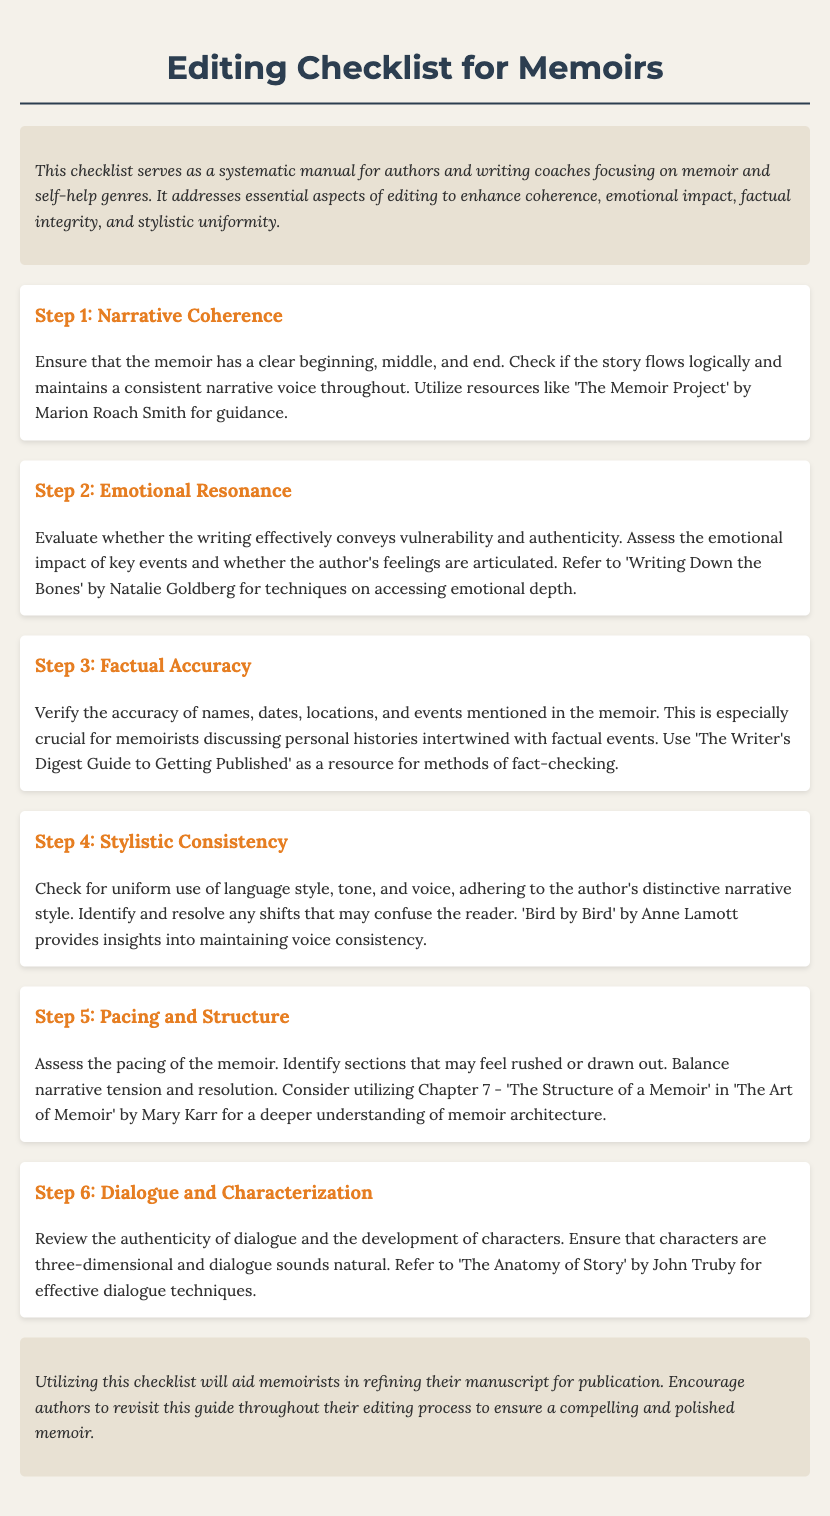What is the title of the document? The title is prominently displayed at the top of the document.
Answer: Editing Checklist for Memoirs How many checklist items are there? The checklist contains several sections that outline different editing aspects.
Answer: Six Which author is mentioned for emotional resonance techniques? The document references specific authors for guidance on various editing aspects, including emotional resonance.
Answer: Natalie Goldberg What aspect of editing does the third checklist item address? Each checklist item focuses on different crucial elements needed for memoir editing.
Answer: Factual Accuracy What is the focus of the introduction section? The introduction provides an overview of the purpose and scope of the checklist.
Answer: Essential aspects of editing What type of resource is mentioned for verifying factual accuracy? The checklist suggests resources that authors can use to improve their writing quality.
Answer: The Writer's Digest Guide to Getting Published Who wrote "The Art of Memoir"? The document lists authors who have published notable works relevant to the editing process.
Answer: Mary Karr What emotional quality is assessed in the second checklist item? Each section focuses on specific elements, highlighting different attributes memoir writers should consider.
Answer: Vulnerability and authenticity 